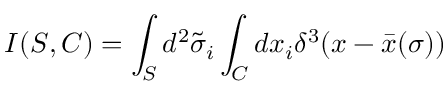<formula> <loc_0><loc_0><loc_500><loc_500>I ( S , C ) = \int _ { S } d ^ { 2 } \tilde { \sigma } _ { i } \int _ { C } d x _ { i } \delta ^ { 3 } ( x - \bar { x } ( \sigma ) )</formula> 